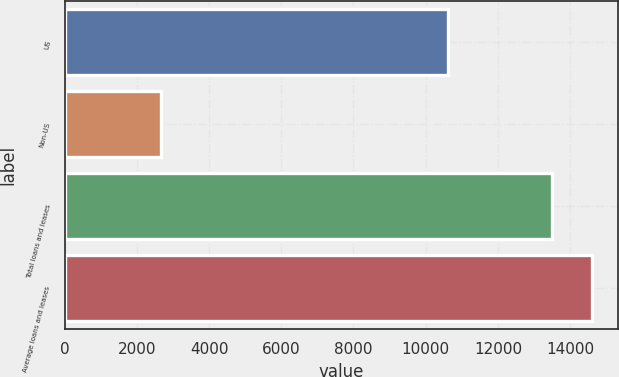<chart> <loc_0><loc_0><loc_500><loc_500><bar_chart><fcel>US<fcel>Non-US<fcel>Total loans and leases<fcel>Average loans and leases<nl><fcel>10623<fcel>2654<fcel>13486<fcel>14598.7<nl></chart> 